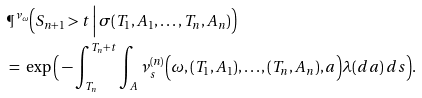Convert formula to latex. <formula><loc_0><loc_0><loc_500><loc_500>& \P ^ { \nu _ { \omega } } \Big ( S _ { n + 1 } > t \, \Big | \, \sigma ( T _ { 1 } , A _ { 1 } , \dots , T _ { n } , A _ { n } ) \Big ) \\ & = \ \exp \Big ( - \int _ { T _ { n } } ^ { T _ { n } + t } \int _ { A } \nu _ { s } ^ { ( n ) } \Big ( \omega , ( T _ { 1 } , A _ { 1 } ) , \dots , ( T _ { n } , A _ { n } ) , a \Big ) \lambda ( d a ) \, d s \Big ) .</formula> 